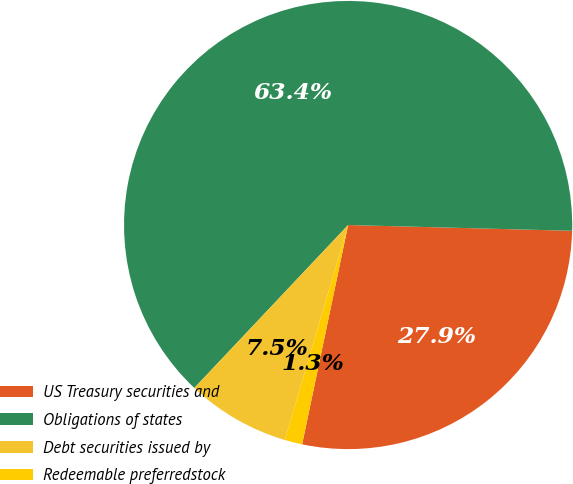Convert chart to OTSL. <chart><loc_0><loc_0><loc_500><loc_500><pie_chart><fcel>US Treasury securities and<fcel>Obligations of states<fcel>Debt securities issued by<fcel>Redeemable preferredstock<nl><fcel>27.88%<fcel>63.37%<fcel>7.48%<fcel>1.27%<nl></chart> 